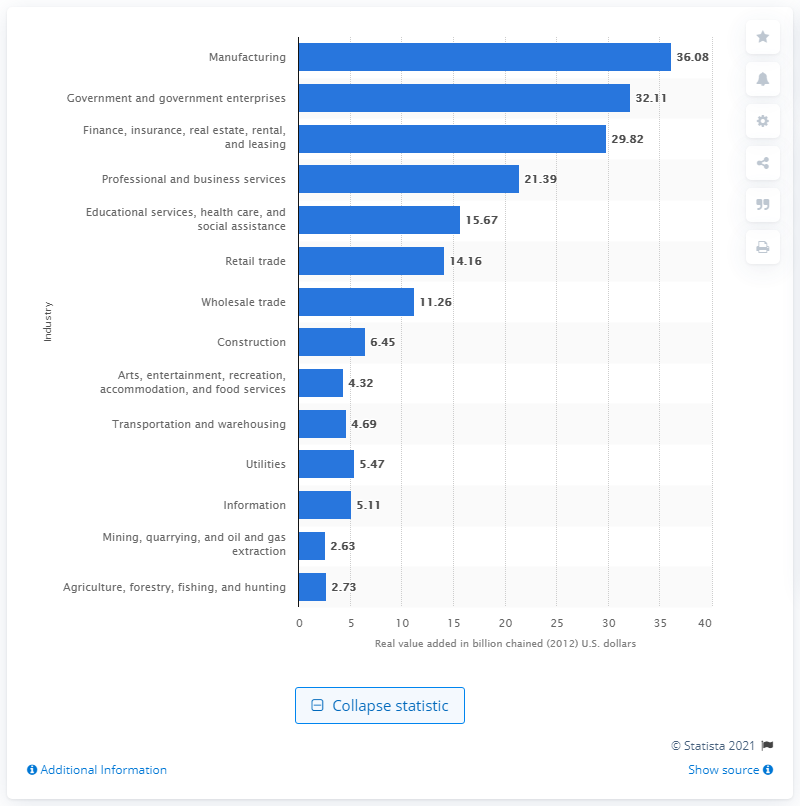Draw attention to some important aspects in this diagram. In 2020, the manufacturing industry contributed a significant amount to Alabama's Gross Domestic Product, with a value of 36.08. 